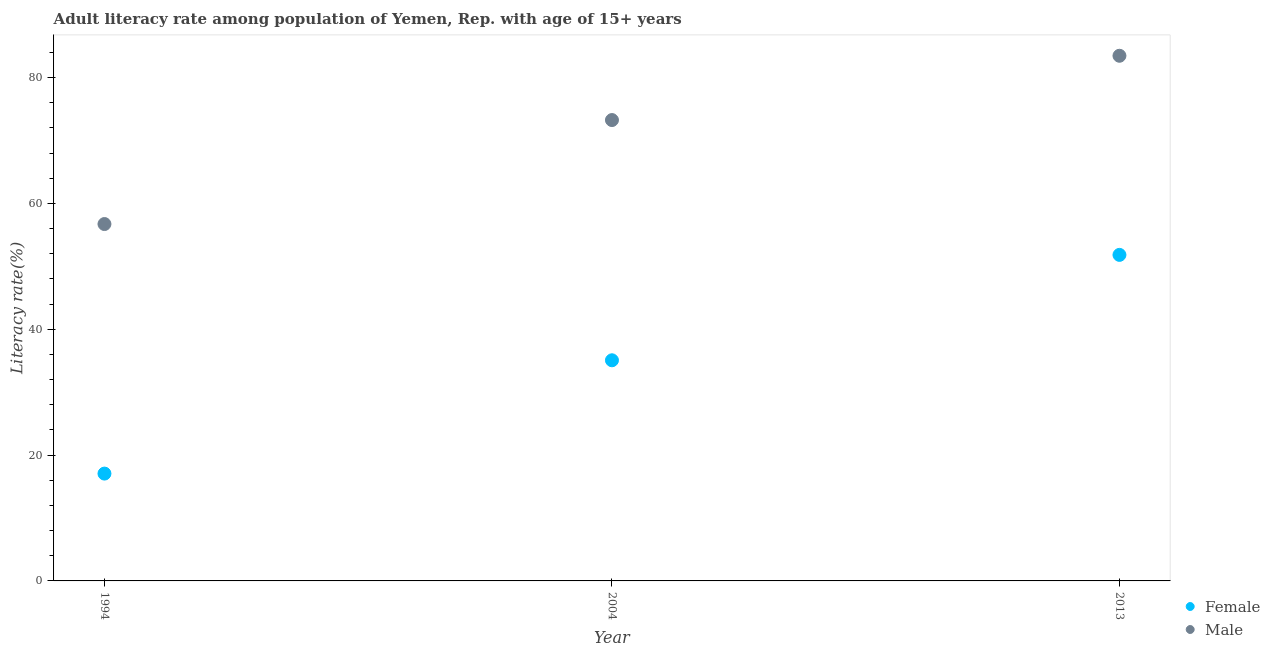Is the number of dotlines equal to the number of legend labels?
Give a very brief answer. Yes. What is the female adult literacy rate in 1994?
Your answer should be very brief. 17.06. Across all years, what is the maximum male adult literacy rate?
Give a very brief answer. 83.47. Across all years, what is the minimum female adult literacy rate?
Your response must be concise. 17.06. What is the total female adult literacy rate in the graph?
Provide a short and direct response. 103.95. What is the difference between the male adult literacy rate in 2004 and that in 2013?
Your answer should be very brief. -10.22. What is the difference between the female adult literacy rate in 2013 and the male adult literacy rate in 2004?
Offer a terse response. -21.43. What is the average male adult literacy rate per year?
Your response must be concise. 71.15. In the year 1994, what is the difference between the male adult literacy rate and female adult literacy rate?
Your response must be concise. 39.67. What is the ratio of the male adult literacy rate in 1994 to that in 2004?
Ensure brevity in your answer.  0.77. Is the male adult literacy rate in 2004 less than that in 2013?
Your answer should be compact. Yes. What is the difference between the highest and the second highest male adult literacy rate?
Keep it short and to the point. 10.22. What is the difference between the highest and the lowest female adult literacy rate?
Offer a very short reply. 34.76. Is the sum of the male adult literacy rate in 2004 and 2013 greater than the maximum female adult literacy rate across all years?
Offer a very short reply. Yes. Is the female adult literacy rate strictly less than the male adult literacy rate over the years?
Your response must be concise. Yes. How many years are there in the graph?
Offer a terse response. 3. Are the values on the major ticks of Y-axis written in scientific E-notation?
Offer a very short reply. No. Where does the legend appear in the graph?
Your response must be concise. Bottom right. How many legend labels are there?
Keep it short and to the point. 2. How are the legend labels stacked?
Your response must be concise. Vertical. What is the title of the graph?
Your response must be concise. Adult literacy rate among population of Yemen, Rep. with age of 15+ years. Does "Public credit registry" appear as one of the legend labels in the graph?
Offer a terse response. No. What is the label or title of the X-axis?
Keep it short and to the point. Year. What is the label or title of the Y-axis?
Your answer should be compact. Literacy rate(%). What is the Literacy rate(%) in Female in 1994?
Your response must be concise. 17.06. What is the Literacy rate(%) in Male in 1994?
Keep it short and to the point. 56.72. What is the Literacy rate(%) of Female in 2004?
Give a very brief answer. 35.07. What is the Literacy rate(%) in Male in 2004?
Your answer should be very brief. 73.25. What is the Literacy rate(%) of Female in 2013?
Your response must be concise. 51.82. What is the Literacy rate(%) in Male in 2013?
Ensure brevity in your answer.  83.47. Across all years, what is the maximum Literacy rate(%) of Female?
Offer a very short reply. 51.82. Across all years, what is the maximum Literacy rate(%) in Male?
Your answer should be compact. 83.47. Across all years, what is the minimum Literacy rate(%) of Female?
Offer a very short reply. 17.06. Across all years, what is the minimum Literacy rate(%) of Male?
Make the answer very short. 56.72. What is the total Literacy rate(%) in Female in the graph?
Ensure brevity in your answer.  103.95. What is the total Literacy rate(%) of Male in the graph?
Your answer should be compact. 213.45. What is the difference between the Literacy rate(%) in Female in 1994 and that in 2004?
Provide a short and direct response. -18.01. What is the difference between the Literacy rate(%) of Male in 1994 and that in 2004?
Give a very brief answer. -16.53. What is the difference between the Literacy rate(%) in Female in 1994 and that in 2013?
Give a very brief answer. -34.76. What is the difference between the Literacy rate(%) of Male in 1994 and that in 2013?
Your response must be concise. -26.75. What is the difference between the Literacy rate(%) of Female in 2004 and that in 2013?
Ensure brevity in your answer.  -16.75. What is the difference between the Literacy rate(%) in Male in 2004 and that in 2013?
Provide a short and direct response. -10.22. What is the difference between the Literacy rate(%) of Female in 1994 and the Literacy rate(%) of Male in 2004?
Your answer should be compact. -56.19. What is the difference between the Literacy rate(%) in Female in 1994 and the Literacy rate(%) in Male in 2013?
Your answer should be very brief. -66.41. What is the difference between the Literacy rate(%) of Female in 2004 and the Literacy rate(%) of Male in 2013?
Make the answer very short. -48.4. What is the average Literacy rate(%) in Female per year?
Provide a succinct answer. 34.65. What is the average Literacy rate(%) in Male per year?
Make the answer very short. 71.15. In the year 1994, what is the difference between the Literacy rate(%) of Female and Literacy rate(%) of Male?
Your response must be concise. -39.67. In the year 2004, what is the difference between the Literacy rate(%) of Female and Literacy rate(%) of Male?
Give a very brief answer. -38.18. In the year 2013, what is the difference between the Literacy rate(%) of Female and Literacy rate(%) of Male?
Give a very brief answer. -31.65. What is the ratio of the Literacy rate(%) of Female in 1994 to that in 2004?
Your answer should be very brief. 0.49. What is the ratio of the Literacy rate(%) of Male in 1994 to that in 2004?
Keep it short and to the point. 0.77. What is the ratio of the Literacy rate(%) of Female in 1994 to that in 2013?
Ensure brevity in your answer.  0.33. What is the ratio of the Literacy rate(%) of Male in 1994 to that in 2013?
Ensure brevity in your answer.  0.68. What is the ratio of the Literacy rate(%) of Female in 2004 to that in 2013?
Offer a terse response. 0.68. What is the ratio of the Literacy rate(%) of Male in 2004 to that in 2013?
Offer a terse response. 0.88. What is the difference between the highest and the second highest Literacy rate(%) of Female?
Provide a short and direct response. 16.75. What is the difference between the highest and the second highest Literacy rate(%) in Male?
Give a very brief answer. 10.22. What is the difference between the highest and the lowest Literacy rate(%) in Female?
Offer a terse response. 34.76. What is the difference between the highest and the lowest Literacy rate(%) in Male?
Keep it short and to the point. 26.75. 